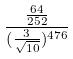Convert formula to latex. <formula><loc_0><loc_0><loc_500><loc_500>\frac { \frac { 6 4 } { 2 5 2 } } { ( \frac { 3 } { \sqrt { 1 0 } } ) ^ { 4 7 6 } }</formula> 